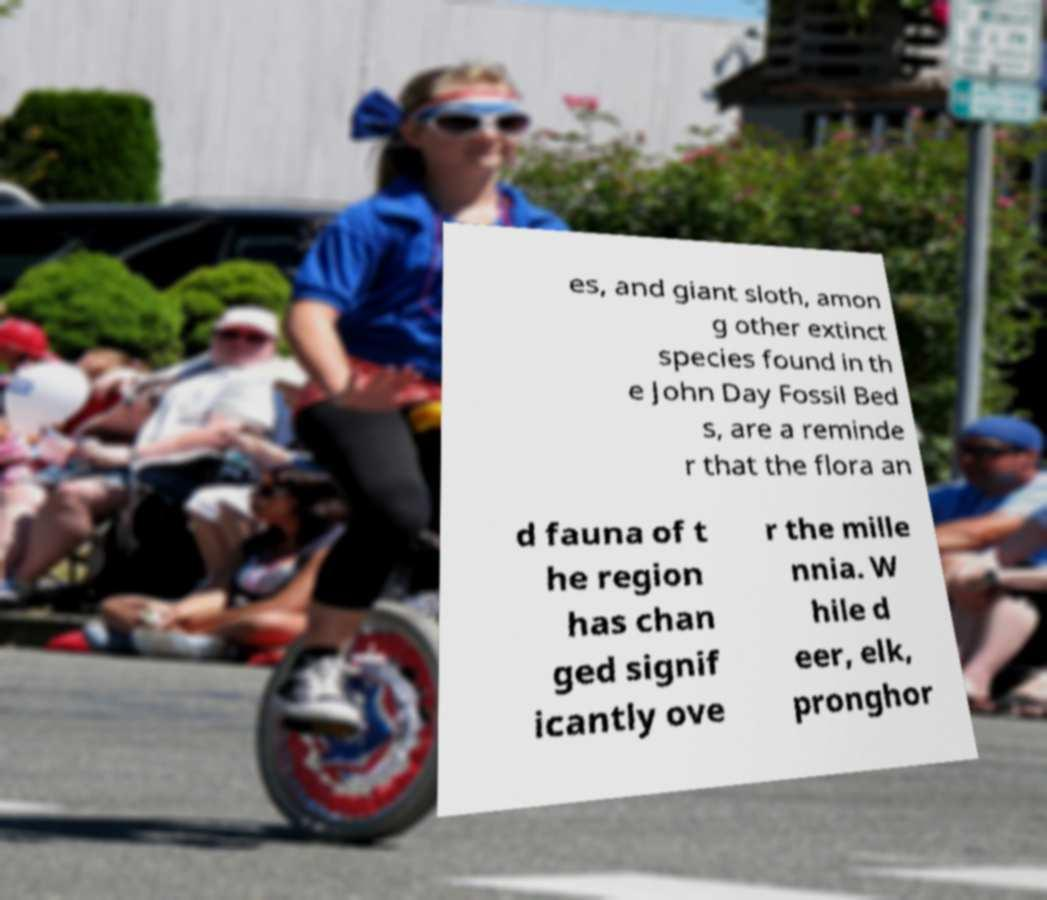What messages or text are displayed in this image? I need them in a readable, typed format. es, and giant sloth, amon g other extinct species found in th e John Day Fossil Bed s, are a reminde r that the flora an d fauna of t he region has chan ged signif icantly ove r the mille nnia. W hile d eer, elk, pronghor 